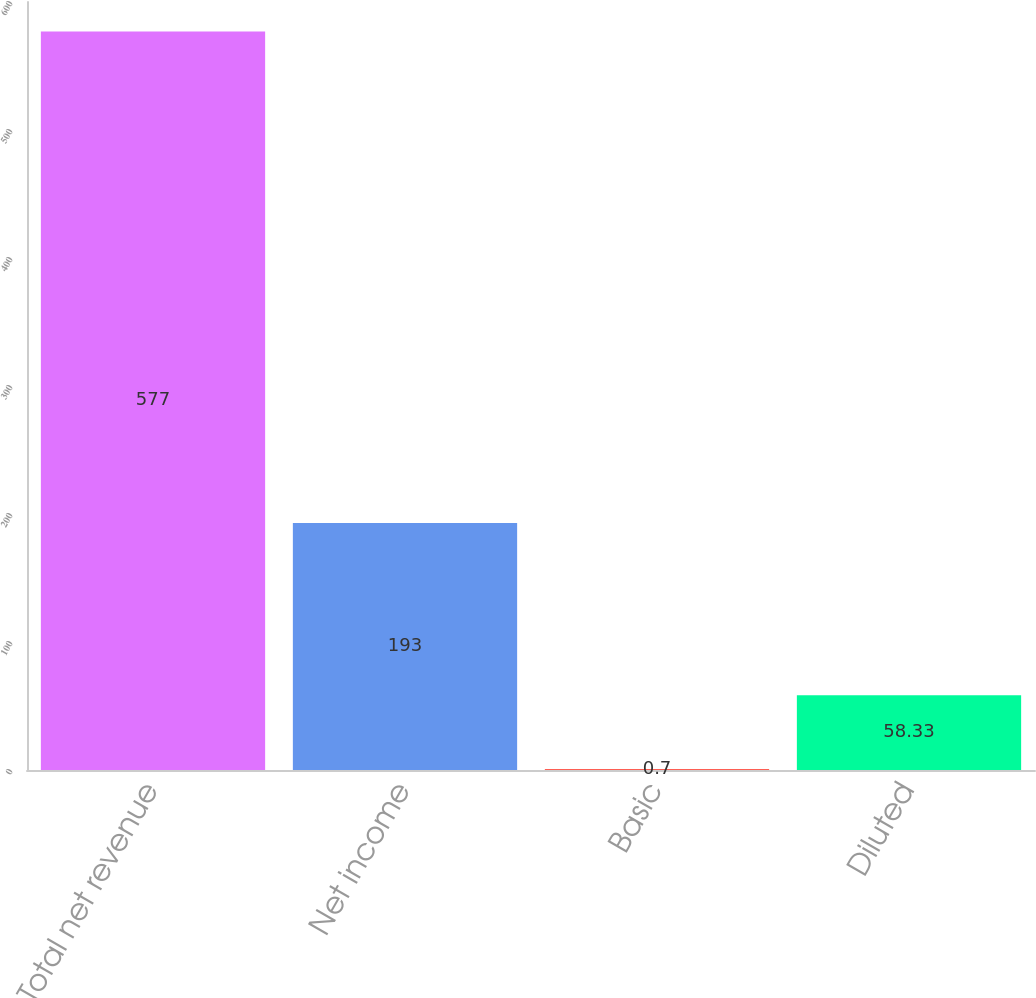<chart> <loc_0><loc_0><loc_500><loc_500><bar_chart><fcel>Total net revenue<fcel>Net income<fcel>Basic<fcel>Diluted<nl><fcel>577<fcel>193<fcel>0.7<fcel>58.33<nl></chart> 